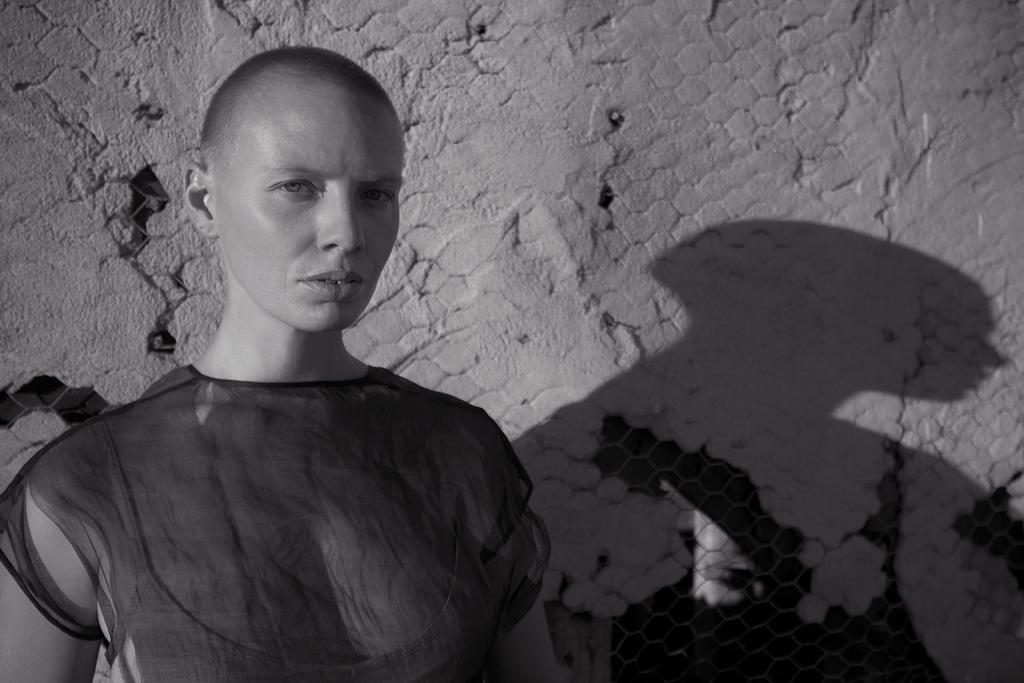Could you give a brief overview of what you see in this image? In this image in the front there is a person standing and in the background there is a wall and there is a fence. 